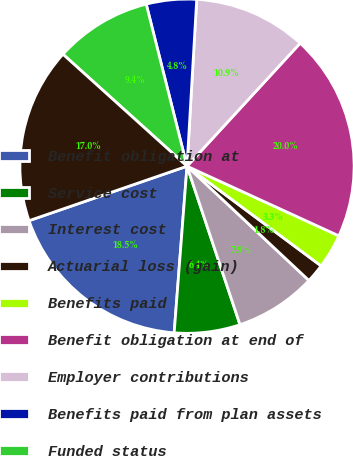Convert chart. <chart><loc_0><loc_0><loc_500><loc_500><pie_chart><fcel>Benefit obligation at<fcel>Service cost<fcel>Interest cost<fcel>Actuarial loss (gain)<fcel>Benefits paid<fcel>Benefit obligation at end of<fcel>Employer contributions<fcel>Benefits paid from plan assets<fcel>Funded status<fcel>Unrecognized net actuarial<nl><fcel>18.49%<fcel>6.36%<fcel>7.88%<fcel>1.81%<fcel>3.33%<fcel>20.01%<fcel>10.91%<fcel>4.85%<fcel>9.39%<fcel>16.97%<nl></chart> 